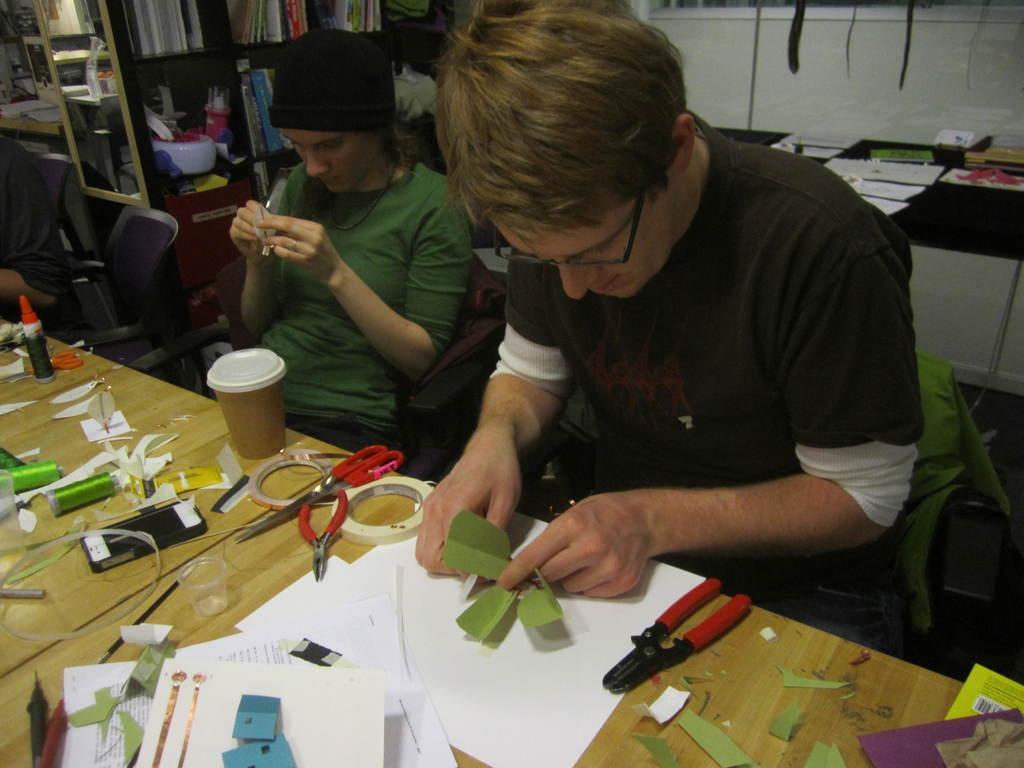Can you describe this image briefly? In this image we can see a man and a woman sitting on the chairs in front of the table and on the table we can see a mobile phone, scissors, cutting pliers, plasters, glass, cup, green color reels, gum bottle and also some pieces of papers. In the background we can see some papers and a book on the black color counter. We can also see some books placed in the racks. We can see an empty chair and also some person on the left. 